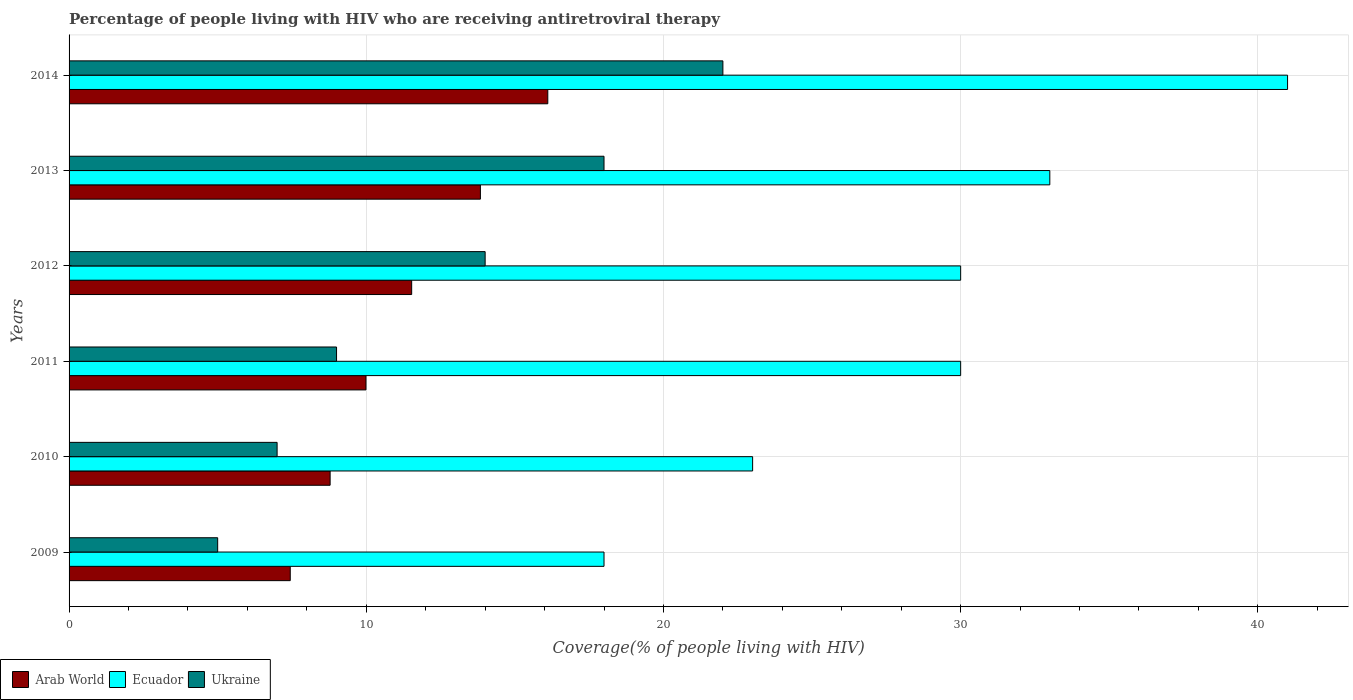How many different coloured bars are there?
Offer a terse response. 3. How many groups of bars are there?
Your response must be concise. 6. Are the number of bars per tick equal to the number of legend labels?
Ensure brevity in your answer.  Yes. How many bars are there on the 4th tick from the bottom?
Ensure brevity in your answer.  3. In how many cases, is the number of bars for a given year not equal to the number of legend labels?
Offer a very short reply. 0. What is the percentage of the HIV infected people who are receiving antiretroviral therapy in Arab World in 2014?
Provide a short and direct response. 16.11. Across all years, what is the maximum percentage of the HIV infected people who are receiving antiretroviral therapy in Ecuador?
Provide a succinct answer. 41. Across all years, what is the minimum percentage of the HIV infected people who are receiving antiretroviral therapy in Ukraine?
Provide a succinct answer. 5. In which year was the percentage of the HIV infected people who are receiving antiretroviral therapy in Ukraine maximum?
Ensure brevity in your answer.  2014. What is the total percentage of the HIV infected people who are receiving antiretroviral therapy in Ecuador in the graph?
Your answer should be compact. 175. What is the difference between the percentage of the HIV infected people who are receiving antiretroviral therapy in Ukraine in 2012 and that in 2013?
Keep it short and to the point. -4. What is the difference between the percentage of the HIV infected people who are receiving antiretroviral therapy in Ecuador in 2013 and the percentage of the HIV infected people who are receiving antiretroviral therapy in Arab World in 2012?
Give a very brief answer. 21.47. What is the average percentage of the HIV infected people who are receiving antiretroviral therapy in Ukraine per year?
Make the answer very short. 12.5. In the year 2010, what is the difference between the percentage of the HIV infected people who are receiving antiretroviral therapy in Ecuador and percentage of the HIV infected people who are receiving antiretroviral therapy in Arab World?
Your answer should be compact. 14.22. In how many years, is the percentage of the HIV infected people who are receiving antiretroviral therapy in Ukraine greater than 28 %?
Give a very brief answer. 0. What is the ratio of the percentage of the HIV infected people who are receiving antiretroviral therapy in Arab World in 2010 to that in 2011?
Offer a terse response. 0.88. What is the difference between the highest and the lowest percentage of the HIV infected people who are receiving antiretroviral therapy in Arab World?
Offer a terse response. 8.67. In how many years, is the percentage of the HIV infected people who are receiving antiretroviral therapy in Arab World greater than the average percentage of the HIV infected people who are receiving antiretroviral therapy in Arab World taken over all years?
Give a very brief answer. 3. What does the 3rd bar from the top in 2011 represents?
Your response must be concise. Arab World. What does the 2nd bar from the bottom in 2010 represents?
Provide a succinct answer. Ecuador. How many bars are there?
Give a very brief answer. 18. What is the difference between two consecutive major ticks on the X-axis?
Provide a short and direct response. 10. Does the graph contain grids?
Give a very brief answer. Yes. Where does the legend appear in the graph?
Offer a very short reply. Bottom left. What is the title of the graph?
Your answer should be very brief. Percentage of people living with HIV who are receiving antiretroviral therapy. Does "Lebanon" appear as one of the legend labels in the graph?
Provide a succinct answer. No. What is the label or title of the X-axis?
Your answer should be very brief. Coverage(% of people living with HIV). What is the Coverage(% of people living with HIV) in Arab World in 2009?
Provide a short and direct response. 7.44. What is the Coverage(% of people living with HIV) of Arab World in 2010?
Give a very brief answer. 8.78. What is the Coverage(% of people living with HIV) in Ecuador in 2010?
Provide a succinct answer. 23. What is the Coverage(% of people living with HIV) in Ukraine in 2010?
Offer a very short reply. 7. What is the Coverage(% of people living with HIV) of Arab World in 2011?
Keep it short and to the point. 9.99. What is the Coverage(% of people living with HIV) in Arab World in 2012?
Your answer should be very brief. 11.53. What is the Coverage(% of people living with HIV) in Ecuador in 2012?
Provide a short and direct response. 30. What is the Coverage(% of people living with HIV) in Ukraine in 2012?
Provide a succinct answer. 14. What is the Coverage(% of people living with HIV) in Arab World in 2013?
Ensure brevity in your answer.  13.84. What is the Coverage(% of people living with HIV) in Ukraine in 2013?
Your answer should be compact. 18. What is the Coverage(% of people living with HIV) in Arab World in 2014?
Your response must be concise. 16.11. What is the Coverage(% of people living with HIV) in Ukraine in 2014?
Your answer should be very brief. 22. Across all years, what is the maximum Coverage(% of people living with HIV) in Arab World?
Your answer should be compact. 16.11. Across all years, what is the maximum Coverage(% of people living with HIV) in Ecuador?
Offer a very short reply. 41. Across all years, what is the maximum Coverage(% of people living with HIV) of Ukraine?
Your response must be concise. 22. Across all years, what is the minimum Coverage(% of people living with HIV) in Arab World?
Give a very brief answer. 7.44. Across all years, what is the minimum Coverage(% of people living with HIV) in Ukraine?
Your answer should be very brief. 5. What is the total Coverage(% of people living with HIV) in Arab World in the graph?
Keep it short and to the point. 67.69. What is the total Coverage(% of people living with HIV) in Ecuador in the graph?
Keep it short and to the point. 175. What is the total Coverage(% of people living with HIV) of Ukraine in the graph?
Ensure brevity in your answer.  75. What is the difference between the Coverage(% of people living with HIV) of Arab World in 2009 and that in 2010?
Provide a short and direct response. -1.34. What is the difference between the Coverage(% of people living with HIV) of Ukraine in 2009 and that in 2010?
Make the answer very short. -2. What is the difference between the Coverage(% of people living with HIV) of Arab World in 2009 and that in 2011?
Offer a very short reply. -2.55. What is the difference between the Coverage(% of people living with HIV) of Ecuador in 2009 and that in 2011?
Your answer should be very brief. -12. What is the difference between the Coverage(% of people living with HIV) in Arab World in 2009 and that in 2012?
Provide a short and direct response. -4.09. What is the difference between the Coverage(% of people living with HIV) in Arab World in 2009 and that in 2013?
Offer a terse response. -6.4. What is the difference between the Coverage(% of people living with HIV) in Ecuador in 2009 and that in 2013?
Provide a short and direct response. -15. What is the difference between the Coverage(% of people living with HIV) in Ukraine in 2009 and that in 2013?
Provide a short and direct response. -13. What is the difference between the Coverage(% of people living with HIV) in Arab World in 2009 and that in 2014?
Make the answer very short. -8.67. What is the difference between the Coverage(% of people living with HIV) of Ecuador in 2009 and that in 2014?
Your answer should be compact. -23. What is the difference between the Coverage(% of people living with HIV) in Ukraine in 2009 and that in 2014?
Provide a short and direct response. -17. What is the difference between the Coverage(% of people living with HIV) in Arab World in 2010 and that in 2011?
Ensure brevity in your answer.  -1.21. What is the difference between the Coverage(% of people living with HIV) in Arab World in 2010 and that in 2012?
Your answer should be very brief. -2.74. What is the difference between the Coverage(% of people living with HIV) of Ecuador in 2010 and that in 2012?
Give a very brief answer. -7. What is the difference between the Coverage(% of people living with HIV) in Ukraine in 2010 and that in 2012?
Ensure brevity in your answer.  -7. What is the difference between the Coverage(% of people living with HIV) of Arab World in 2010 and that in 2013?
Your response must be concise. -5.06. What is the difference between the Coverage(% of people living with HIV) of Arab World in 2010 and that in 2014?
Your answer should be very brief. -7.32. What is the difference between the Coverage(% of people living with HIV) in Arab World in 2011 and that in 2012?
Your response must be concise. -1.54. What is the difference between the Coverage(% of people living with HIV) of Ecuador in 2011 and that in 2012?
Provide a short and direct response. 0. What is the difference between the Coverage(% of people living with HIV) in Arab World in 2011 and that in 2013?
Make the answer very short. -3.85. What is the difference between the Coverage(% of people living with HIV) of Ukraine in 2011 and that in 2013?
Ensure brevity in your answer.  -9. What is the difference between the Coverage(% of people living with HIV) in Arab World in 2011 and that in 2014?
Offer a very short reply. -6.12. What is the difference between the Coverage(% of people living with HIV) in Ecuador in 2011 and that in 2014?
Your answer should be very brief. -11. What is the difference between the Coverage(% of people living with HIV) in Ukraine in 2011 and that in 2014?
Provide a succinct answer. -13. What is the difference between the Coverage(% of people living with HIV) in Arab World in 2012 and that in 2013?
Make the answer very short. -2.31. What is the difference between the Coverage(% of people living with HIV) of Ecuador in 2012 and that in 2013?
Your answer should be compact. -3. What is the difference between the Coverage(% of people living with HIV) of Ukraine in 2012 and that in 2013?
Offer a terse response. -4. What is the difference between the Coverage(% of people living with HIV) of Arab World in 2012 and that in 2014?
Your answer should be compact. -4.58. What is the difference between the Coverage(% of people living with HIV) in Ukraine in 2012 and that in 2014?
Provide a short and direct response. -8. What is the difference between the Coverage(% of people living with HIV) in Arab World in 2013 and that in 2014?
Ensure brevity in your answer.  -2.27. What is the difference between the Coverage(% of people living with HIV) of Ecuador in 2013 and that in 2014?
Provide a succinct answer. -8. What is the difference between the Coverage(% of people living with HIV) in Arab World in 2009 and the Coverage(% of people living with HIV) in Ecuador in 2010?
Make the answer very short. -15.56. What is the difference between the Coverage(% of people living with HIV) of Arab World in 2009 and the Coverage(% of people living with HIV) of Ukraine in 2010?
Offer a terse response. 0.44. What is the difference between the Coverage(% of people living with HIV) in Arab World in 2009 and the Coverage(% of people living with HIV) in Ecuador in 2011?
Your answer should be very brief. -22.56. What is the difference between the Coverage(% of people living with HIV) of Arab World in 2009 and the Coverage(% of people living with HIV) of Ukraine in 2011?
Provide a succinct answer. -1.56. What is the difference between the Coverage(% of people living with HIV) in Ecuador in 2009 and the Coverage(% of people living with HIV) in Ukraine in 2011?
Your response must be concise. 9. What is the difference between the Coverage(% of people living with HIV) of Arab World in 2009 and the Coverage(% of people living with HIV) of Ecuador in 2012?
Provide a succinct answer. -22.56. What is the difference between the Coverage(% of people living with HIV) of Arab World in 2009 and the Coverage(% of people living with HIV) of Ukraine in 2012?
Ensure brevity in your answer.  -6.56. What is the difference between the Coverage(% of people living with HIV) of Arab World in 2009 and the Coverage(% of people living with HIV) of Ecuador in 2013?
Provide a short and direct response. -25.56. What is the difference between the Coverage(% of people living with HIV) of Arab World in 2009 and the Coverage(% of people living with HIV) of Ukraine in 2013?
Offer a terse response. -10.56. What is the difference between the Coverage(% of people living with HIV) in Ecuador in 2009 and the Coverage(% of people living with HIV) in Ukraine in 2013?
Offer a terse response. 0. What is the difference between the Coverage(% of people living with HIV) in Arab World in 2009 and the Coverage(% of people living with HIV) in Ecuador in 2014?
Your answer should be very brief. -33.56. What is the difference between the Coverage(% of people living with HIV) of Arab World in 2009 and the Coverage(% of people living with HIV) of Ukraine in 2014?
Offer a very short reply. -14.56. What is the difference between the Coverage(% of people living with HIV) of Arab World in 2010 and the Coverage(% of people living with HIV) of Ecuador in 2011?
Provide a short and direct response. -21.22. What is the difference between the Coverage(% of people living with HIV) in Arab World in 2010 and the Coverage(% of people living with HIV) in Ukraine in 2011?
Ensure brevity in your answer.  -0.22. What is the difference between the Coverage(% of people living with HIV) in Arab World in 2010 and the Coverage(% of people living with HIV) in Ecuador in 2012?
Offer a very short reply. -21.22. What is the difference between the Coverage(% of people living with HIV) of Arab World in 2010 and the Coverage(% of people living with HIV) of Ukraine in 2012?
Give a very brief answer. -5.22. What is the difference between the Coverage(% of people living with HIV) of Arab World in 2010 and the Coverage(% of people living with HIV) of Ecuador in 2013?
Ensure brevity in your answer.  -24.22. What is the difference between the Coverage(% of people living with HIV) of Arab World in 2010 and the Coverage(% of people living with HIV) of Ukraine in 2013?
Keep it short and to the point. -9.22. What is the difference between the Coverage(% of people living with HIV) in Ecuador in 2010 and the Coverage(% of people living with HIV) in Ukraine in 2013?
Make the answer very short. 5. What is the difference between the Coverage(% of people living with HIV) in Arab World in 2010 and the Coverage(% of people living with HIV) in Ecuador in 2014?
Ensure brevity in your answer.  -32.22. What is the difference between the Coverage(% of people living with HIV) of Arab World in 2010 and the Coverage(% of people living with HIV) of Ukraine in 2014?
Ensure brevity in your answer.  -13.22. What is the difference between the Coverage(% of people living with HIV) of Arab World in 2011 and the Coverage(% of people living with HIV) of Ecuador in 2012?
Ensure brevity in your answer.  -20.01. What is the difference between the Coverage(% of people living with HIV) in Arab World in 2011 and the Coverage(% of people living with HIV) in Ukraine in 2012?
Provide a short and direct response. -4.01. What is the difference between the Coverage(% of people living with HIV) of Ecuador in 2011 and the Coverage(% of people living with HIV) of Ukraine in 2012?
Give a very brief answer. 16. What is the difference between the Coverage(% of people living with HIV) in Arab World in 2011 and the Coverage(% of people living with HIV) in Ecuador in 2013?
Give a very brief answer. -23.01. What is the difference between the Coverage(% of people living with HIV) in Arab World in 2011 and the Coverage(% of people living with HIV) in Ukraine in 2013?
Your answer should be compact. -8.01. What is the difference between the Coverage(% of people living with HIV) in Ecuador in 2011 and the Coverage(% of people living with HIV) in Ukraine in 2013?
Ensure brevity in your answer.  12. What is the difference between the Coverage(% of people living with HIV) in Arab World in 2011 and the Coverage(% of people living with HIV) in Ecuador in 2014?
Provide a succinct answer. -31.01. What is the difference between the Coverage(% of people living with HIV) in Arab World in 2011 and the Coverage(% of people living with HIV) in Ukraine in 2014?
Offer a very short reply. -12.01. What is the difference between the Coverage(% of people living with HIV) of Arab World in 2012 and the Coverage(% of people living with HIV) of Ecuador in 2013?
Your answer should be very brief. -21.47. What is the difference between the Coverage(% of people living with HIV) of Arab World in 2012 and the Coverage(% of people living with HIV) of Ukraine in 2013?
Your answer should be compact. -6.47. What is the difference between the Coverage(% of people living with HIV) in Arab World in 2012 and the Coverage(% of people living with HIV) in Ecuador in 2014?
Your answer should be very brief. -29.47. What is the difference between the Coverage(% of people living with HIV) in Arab World in 2012 and the Coverage(% of people living with HIV) in Ukraine in 2014?
Your answer should be compact. -10.47. What is the difference between the Coverage(% of people living with HIV) of Arab World in 2013 and the Coverage(% of people living with HIV) of Ecuador in 2014?
Provide a succinct answer. -27.16. What is the difference between the Coverage(% of people living with HIV) in Arab World in 2013 and the Coverage(% of people living with HIV) in Ukraine in 2014?
Provide a short and direct response. -8.16. What is the average Coverage(% of people living with HIV) in Arab World per year?
Provide a succinct answer. 11.28. What is the average Coverage(% of people living with HIV) of Ecuador per year?
Your response must be concise. 29.17. In the year 2009, what is the difference between the Coverage(% of people living with HIV) of Arab World and Coverage(% of people living with HIV) of Ecuador?
Provide a short and direct response. -10.56. In the year 2009, what is the difference between the Coverage(% of people living with HIV) of Arab World and Coverage(% of people living with HIV) of Ukraine?
Your answer should be compact. 2.44. In the year 2010, what is the difference between the Coverage(% of people living with HIV) of Arab World and Coverage(% of people living with HIV) of Ecuador?
Your answer should be compact. -14.22. In the year 2010, what is the difference between the Coverage(% of people living with HIV) of Arab World and Coverage(% of people living with HIV) of Ukraine?
Provide a succinct answer. 1.78. In the year 2010, what is the difference between the Coverage(% of people living with HIV) of Ecuador and Coverage(% of people living with HIV) of Ukraine?
Ensure brevity in your answer.  16. In the year 2011, what is the difference between the Coverage(% of people living with HIV) in Arab World and Coverage(% of people living with HIV) in Ecuador?
Ensure brevity in your answer.  -20.01. In the year 2011, what is the difference between the Coverage(% of people living with HIV) in Arab World and Coverage(% of people living with HIV) in Ukraine?
Offer a very short reply. 0.99. In the year 2012, what is the difference between the Coverage(% of people living with HIV) in Arab World and Coverage(% of people living with HIV) in Ecuador?
Provide a short and direct response. -18.47. In the year 2012, what is the difference between the Coverage(% of people living with HIV) of Arab World and Coverage(% of people living with HIV) of Ukraine?
Offer a very short reply. -2.47. In the year 2012, what is the difference between the Coverage(% of people living with HIV) in Ecuador and Coverage(% of people living with HIV) in Ukraine?
Offer a very short reply. 16. In the year 2013, what is the difference between the Coverage(% of people living with HIV) of Arab World and Coverage(% of people living with HIV) of Ecuador?
Keep it short and to the point. -19.16. In the year 2013, what is the difference between the Coverage(% of people living with HIV) in Arab World and Coverage(% of people living with HIV) in Ukraine?
Ensure brevity in your answer.  -4.16. In the year 2014, what is the difference between the Coverage(% of people living with HIV) of Arab World and Coverage(% of people living with HIV) of Ecuador?
Make the answer very short. -24.89. In the year 2014, what is the difference between the Coverage(% of people living with HIV) of Arab World and Coverage(% of people living with HIV) of Ukraine?
Ensure brevity in your answer.  -5.89. What is the ratio of the Coverage(% of people living with HIV) in Arab World in 2009 to that in 2010?
Offer a very short reply. 0.85. What is the ratio of the Coverage(% of people living with HIV) of Ecuador in 2009 to that in 2010?
Keep it short and to the point. 0.78. What is the ratio of the Coverage(% of people living with HIV) of Ukraine in 2009 to that in 2010?
Your answer should be compact. 0.71. What is the ratio of the Coverage(% of people living with HIV) of Arab World in 2009 to that in 2011?
Your answer should be very brief. 0.74. What is the ratio of the Coverage(% of people living with HIV) in Ukraine in 2009 to that in 2011?
Provide a short and direct response. 0.56. What is the ratio of the Coverage(% of people living with HIV) in Arab World in 2009 to that in 2012?
Give a very brief answer. 0.65. What is the ratio of the Coverage(% of people living with HIV) of Ukraine in 2009 to that in 2012?
Offer a terse response. 0.36. What is the ratio of the Coverage(% of people living with HIV) in Arab World in 2009 to that in 2013?
Offer a very short reply. 0.54. What is the ratio of the Coverage(% of people living with HIV) in Ecuador in 2009 to that in 2013?
Offer a terse response. 0.55. What is the ratio of the Coverage(% of people living with HIV) of Ukraine in 2009 to that in 2013?
Keep it short and to the point. 0.28. What is the ratio of the Coverage(% of people living with HIV) in Arab World in 2009 to that in 2014?
Your answer should be very brief. 0.46. What is the ratio of the Coverage(% of people living with HIV) of Ecuador in 2009 to that in 2014?
Provide a succinct answer. 0.44. What is the ratio of the Coverage(% of people living with HIV) in Ukraine in 2009 to that in 2014?
Your response must be concise. 0.23. What is the ratio of the Coverage(% of people living with HIV) in Arab World in 2010 to that in 2011?
Give a very brief answer. 0.88. What is the ratio of the Coverage(% of people living with HIV) in Ecuador in 2010 to that in 2011?
Offer a very short reply. 0.77. What is the ratio of the Coverage(% of people living with HIV) of Ukraine in 2010 to that in 2011?
Ensure brevity in your answer.  0.78. What is the ratio of the Coverage(% of people living with HIV) in Arab World in 2010 to that in 2012?
Provide a short and direct response. 0.76. What is the ratio of the Coverage(% of people living with HIV) in Ecuador in 2010 to that in 2012?
Ensure brevity in your answer.  0.77. What is the ratio of the Coverage(% of people living with HIV) of Ukraine in 2010 to that in 2012?
Your response must be concise. 0.5. What is the ratio of the Coverage(% of people living with HIV) of Arab World in 2010 to that in 2013?
Make the answer very short. 0.63. What is the ratio of the Coverage(% of people living with HIV) of Ecuador in 2010 to that in 2013?
Offer a terse response. 0.7. What is the ratio of the Coverage(% of people living with HIV) of Ukraine in 2010 to that in 2013?
Your response must be concise. 0.39. What is the ratio of the Coverage(% of people living with HIV) of Arab World in 2010 to that in 2014?
Keep it short and to the point. 0.55. What is the ratio of the Coverage(% of people living with HIV) of Ecuador in 2010 to that in 2014?
Your answer should be very brief. 0.56. What is the ratio of the Coverage(% of people living with HIV) in Ukraine in 2010 to that in 2014?
Keep it short and to the point. 0.32. What is the ratio of the Coverage(% of people living with HIV) in Arab World in 2011 to that in 2012?
Provide a short and direct response. 0.87. What is the ratio of the Coverage(% of people living with HIV) of Ecuador in 2011 to that in 2012?
Your answer should be very brief. 1. What is the ratio of the Coverage(% of people living with HIV) in Ukraine in 2011 to that in 2012?
Your answer should be very brief. 0.64. What is the ratio of the Coverage(% of people living with HIV) in Arab World in 2011 to that in 2013?
Keep it short and to the point. 0.72. What is the ratio of the Coverage(% of people living with HIV) of Ukraine in 2011 to that in 2013?
Offer a terse response. 0.5. What is the ratio of the Coverage(% of people living with HIV) in Arab World in 2011 to that in 2014?
Make the answer very short. 0.62. What is the ratio of the Coverage(% of people living with HIV) in Ecuador in 2011 to that in 2014?
Your response must be concise. 0.73. What is the ratio of the Coverage(% of people living with HIV) of Ukraine in 2011 to that in 2014?
Offer a very short reply. 0.41. What is the ratio of the Coverage(% of people living with HIV) of Arab World in 2012 to that in 2013?
Offer a terse response. 0.83. What is the ratio of the Coverage(% of people living with HIV) in Ecuador in 2012 to that in 2013?
Provide a short and direct response. 0.91. What is the ratio of the Coverage(% of people living with HIV) in Ukraine in 2012 to that in 2013?
Your response must be concise. 0.78. What is the ratio of the Coverage(% of people living with HIV) of Arab World in 2012 to that in 2014?
Ensure brevity in your answer.  0.72. What is the ratio of the Coverage(% of people living with HIV) of Ecuador in 2012 to that in 2014?
Offer a terse response. 0.73. What is the ratio of the Coverage(% of people living with HIV) of Ukraine in 2012 to that in 2014?
Offer a terse response. 0.64. What is the ratio of the Coverage(% of people living with HIV) in Arab World in 2013 to that in 2014?
Provide a short and direct response. 0.86. What is the ratio of the Coverage(% of people living with HIV) in Ecuador in 2013 to that in 2014?
Provide a succinct answer. 0.8. What is the ratio of the Coverage(% of people living with HIV) in Ukraine in 2013 to that in 2014?
Provide a short and direct response. 0.82. What is the difference between the highest and the second highest Coverage(% of people living with HIV) in Arab World?
Offer a terse response. 2.27. What is the difference between the highest and the second highest Coverage(% of people living with HIV) in Ukraine?
Your response must be concise. 4. What is the difference between the highest and the lowest Coverage(% of people living with HIV) in Arab World?
Provide a short and direct response. 8.67. What is the difference between the highest and the lowest Coverage(% of people living with HIV) in Ecuador?
Your answer should be very brief. 23. What is the difference between the highest and the lowest Coverage(% of people living with HIV) in Ukraine?
Keep it short and to the point. 17. 